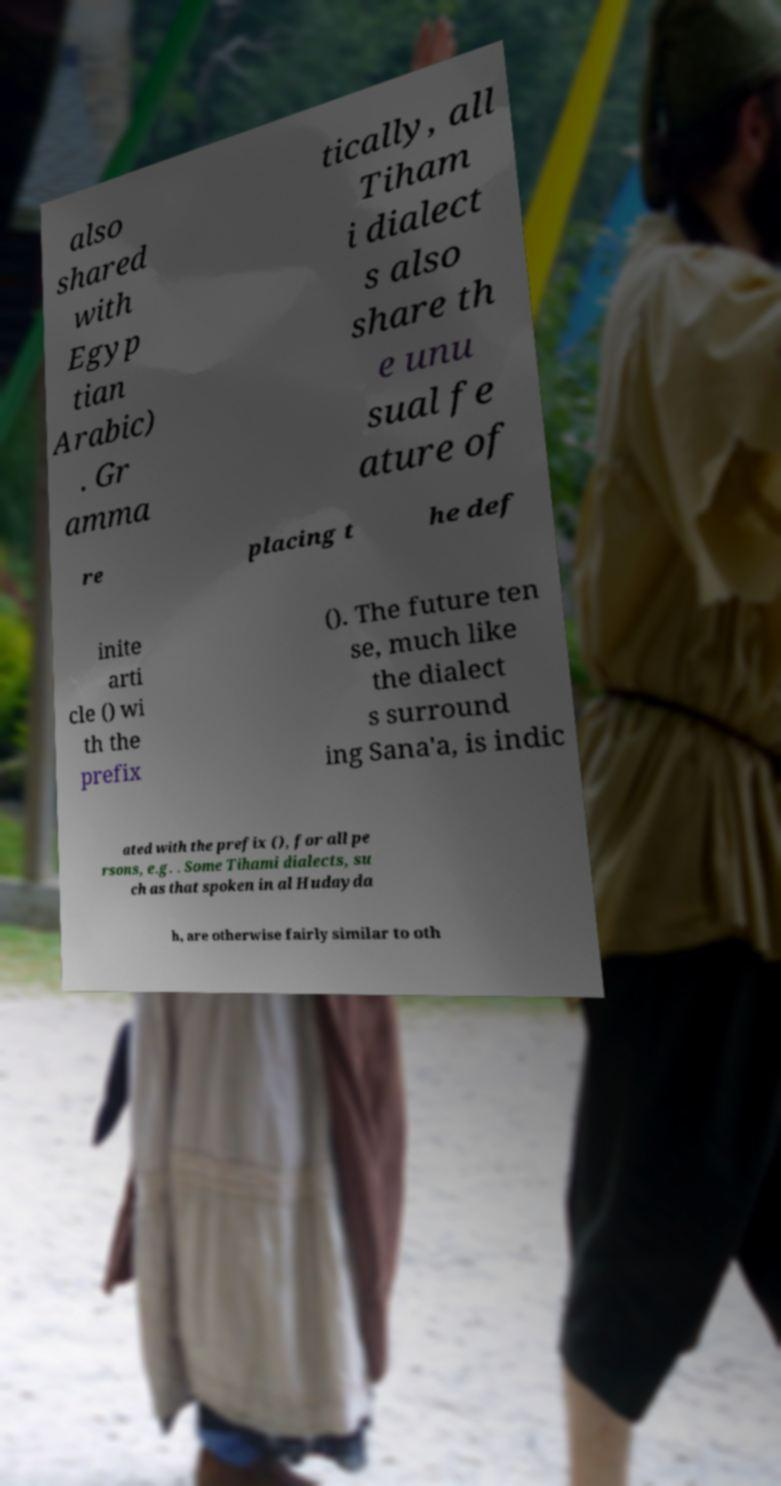Can you accurately transcribe the text from the provided image for me? also shared with Egyp tian Arabic) . Gr amma tically, all Tiham i dialect s also share th e unu sual fe ature of re placing t he def inite arti cle () wi th the prefix (). The future ten se, much like the dialect s surround ing Sana'a, is indic ated with the prefix (), for all pe rsons, e.g. . Some Tihami dialects, su ch as that spoken in al Hudayda h, are otherwise fairly similar to oth 